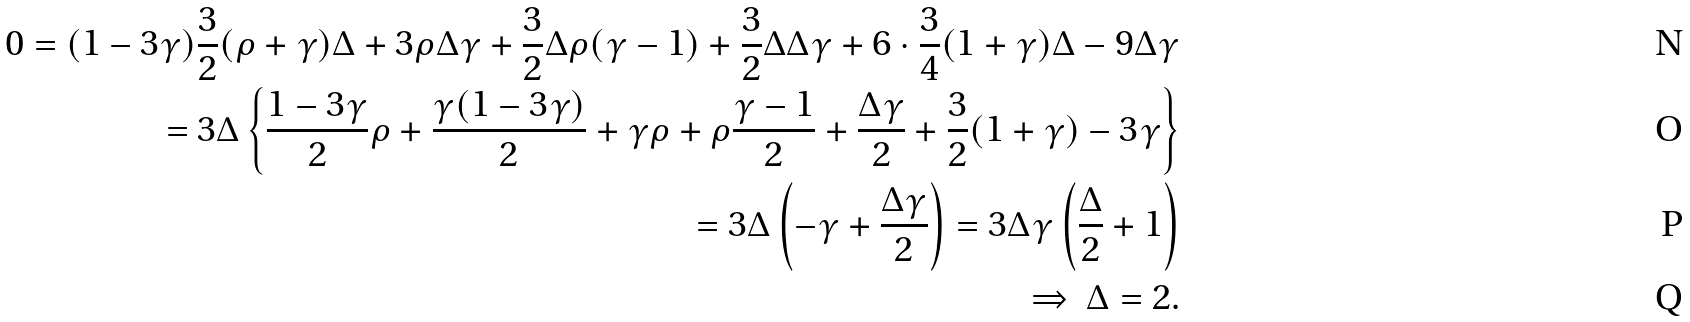Convert formula to latex. <formula><loc_0><loc_0><loc_500><loc_500>0 = ( 1 - 3 \gamma ) \frac { 3 } { 2 } ( \rho + \gamma ) \Delta + 3 \rho \Delta \gamma + \frac { 3 } { 2 } \Delta \rho ( \gamma - 1 ) + \frac { 3 } { 2 } \Delta \Delta \gamma + 6 \cdot \frac { 3 } { 4 } ( 1 + \gamma ) \Delta - 9 \Delta \gamma \\ = 3 \Delta \left \{ \frac { 1 - 3 \gamma } { 2 } \rho + \frac { \gamma ( 1 - 3 \gamma ) } { 2 } + \gamma \rho + \rho \frac { \gamma - 1 } { 2 } + \frac { \Delta \gamma } { 2 } + \frac { 3 } { 2 } ( 1 + \gamma ) - 3 \gamma \right \} \\ = 3 \Delta \left ( - \gamma + \frac { \Delta \gamma } { 2 } \right ) = 3 \Delta \gamma \left ( \frac { \Delta } { 2 } + 1 \right ) \\ \Rightarrow \ \Delta = 2 .</formula> 